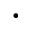<formula> <loc_0><loc_0><loc_500><loc_500>\cdot</formula> 